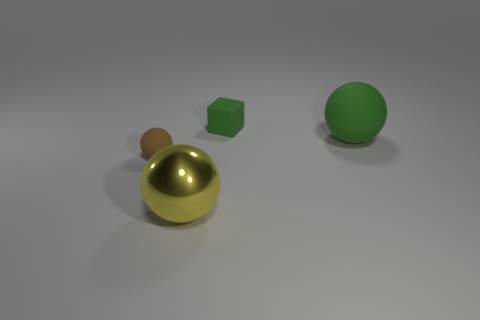What is the color of the large object that is made of the same material as the brown ball?
Provide a succinct answer. Green. What is the shape of the green matte thing behind the rubber ball that is behind the brown ball that is left of the green matte ball?
Your response must be concise. Cube. The cube has what size?
Provide a succinct answer. Small. There is a brown object that is the same material as the big green sphere; what shape is it?
Ensure brevity in your answer.  Sphere. Is the number of large yellow metal balls in front of the tiny brown matte ball less than the number of tiny yellow metallic cylinders?
Your answer should be very brief. No. What is the color of the large ball to the right of the yellow metal object?
Your answer should be compact. Green. What is the material of the sphere that is the same color as the tiny block?
Make the answer very short. Rubber. Is there a big cyan rubber thing that has the same shape as the big metallic thing?
Provide a short and direct response. No. What number of tiny brown objects are the same shape as the yellow metallic object?
Make the answer very short. 1. Does the large matte object have the same color as the cube?
Your answer should be compact. Yes. 